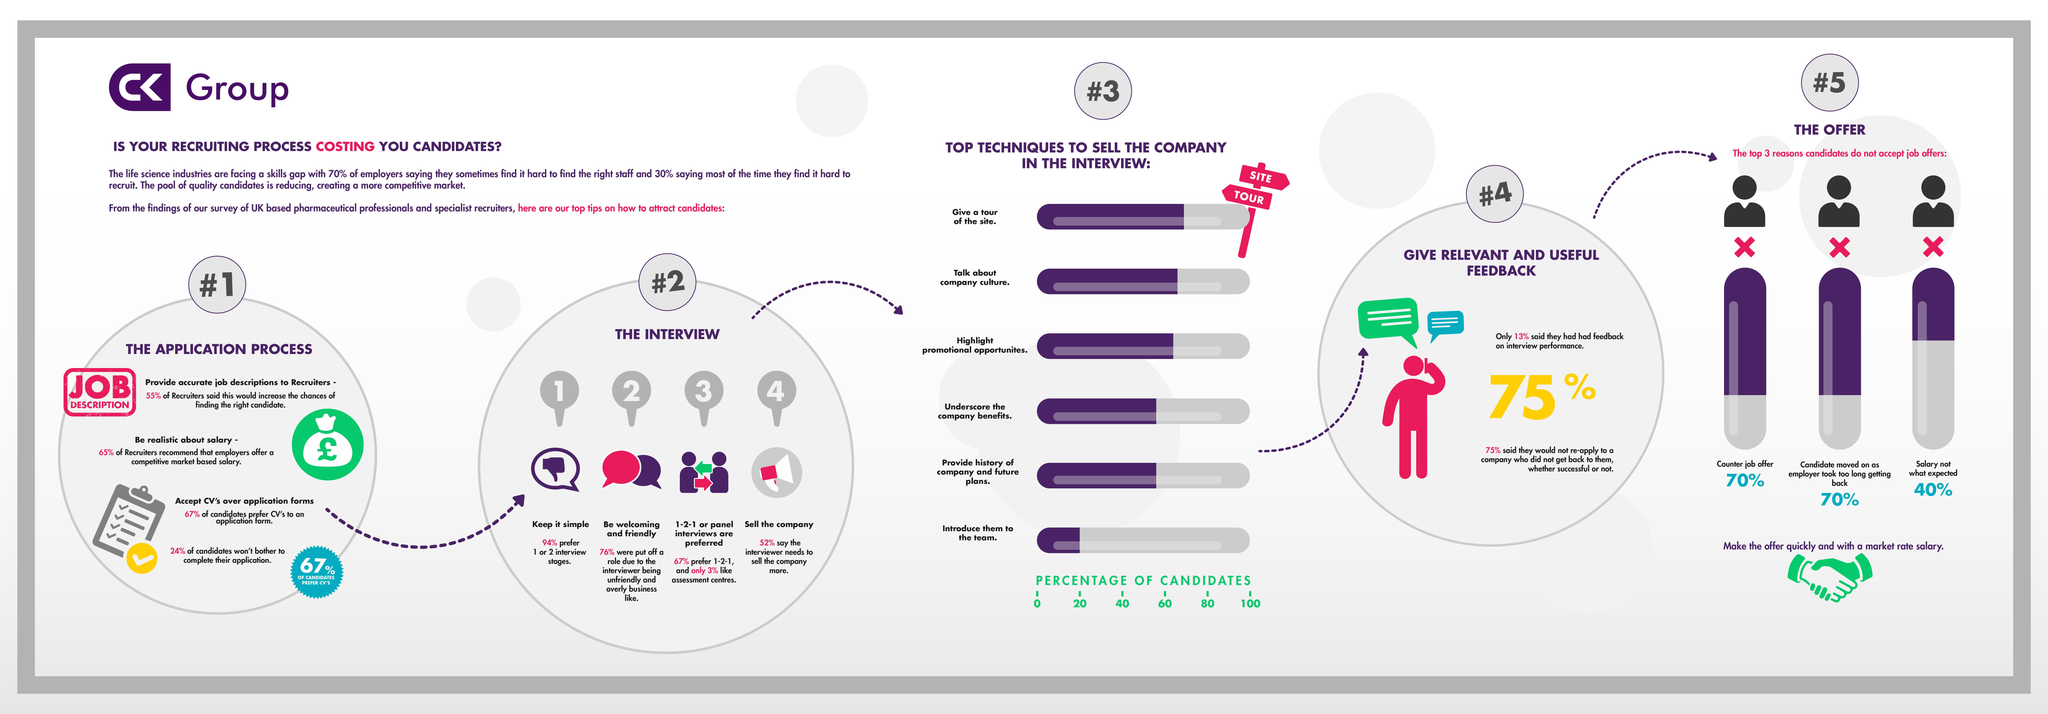Point out several critical features in this image. According to a survey, 67% of candidates prefer using a CV when applying for a job compared to an application form. I would recommend showcasing the company's website during an interview as the most effective technique for selling it by providing a guided tour of the site. 